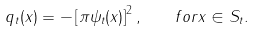Convert formula to latex. <formula><loc_0><loc_0><loc_500><loc_500>q _ { t } ( x ) = - \left [ \pi \psi _ { t } ( x ) \right ] ^ { 2 } , \quad f o r x \in S _ { t } .</formula> 